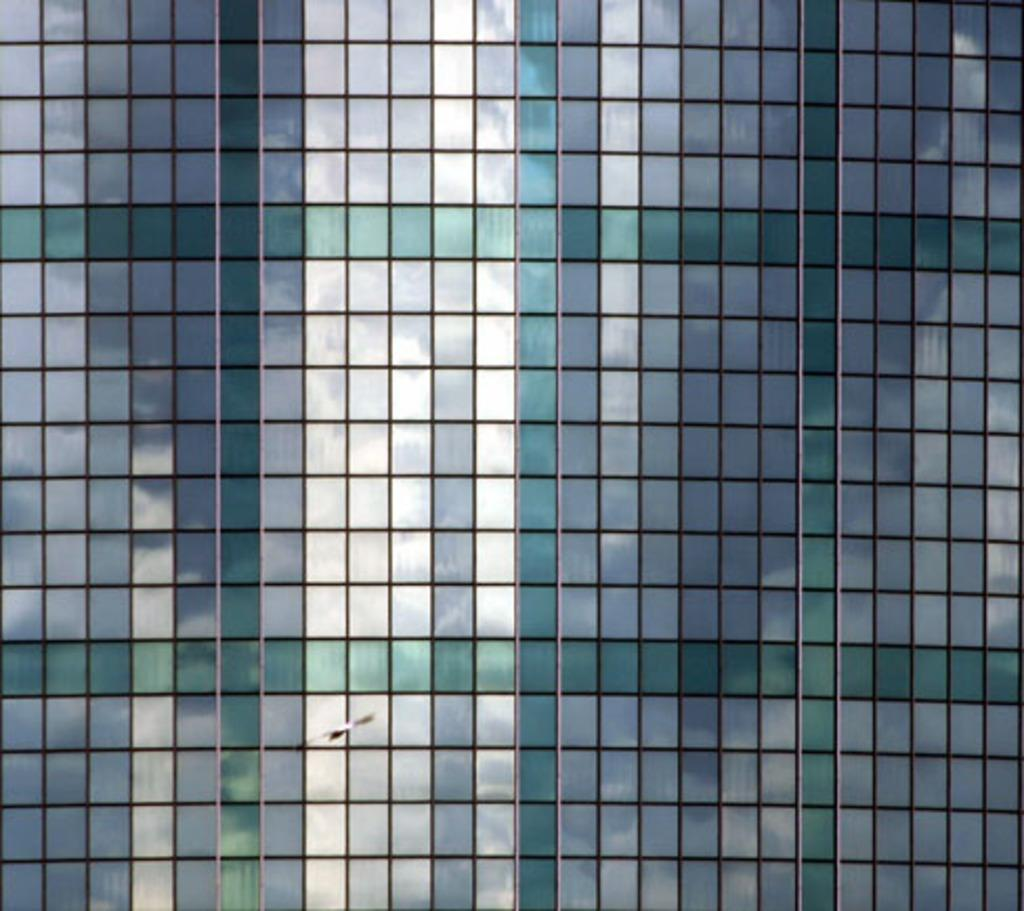What type of structure is present in the image? There is a building in the image. What is happening in the sky in the image? A bird is flying in the image. What type of quartz can be seen in the image? There is no quartz present in the image. How does the bird burst into flames in the image? The bird does not burst into flames in the image; it is simply flying. 